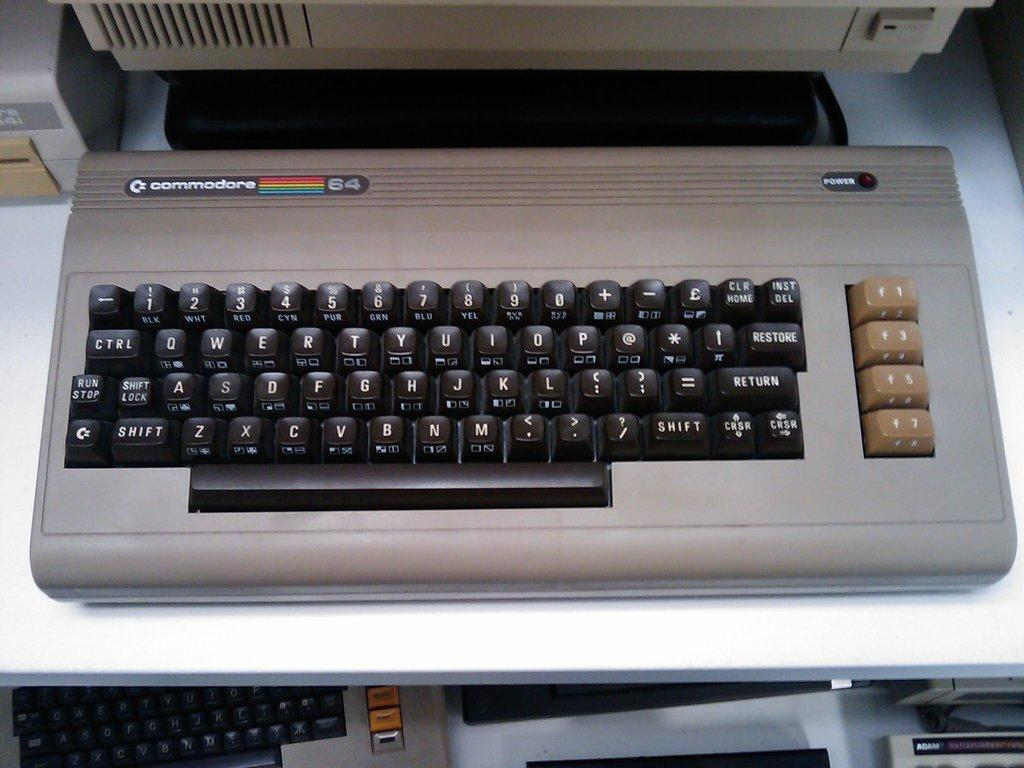What type of objects can be seen in the image? There are keyboards in the image. What colors are present among the objects in the image? There are objects in the image that are white in color and objects that are black in color. What type of territory is being claimed by the quiver in the image? There is no quiver present in the image, so it cannot be claimed to be claiming any territory. 